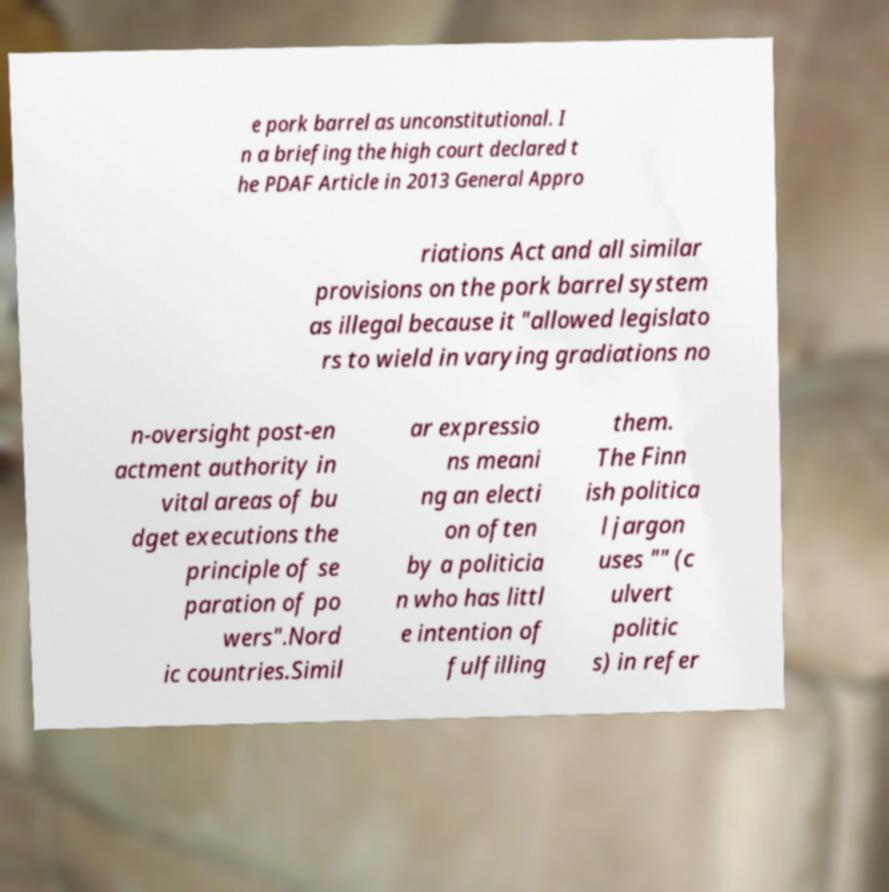There's text embedded in this image that I need extracted. Can you transcribe it verbatim? e pork barrel as unconstitutional. I n a briefing the high court declared t he PDAF Article in 2013 General Appro riations Act and all similar provisions on the pork barrel system as illegal because it "allowed legislato rs to wield in varying gradiations no n-oversight post-en actment authority in vital areas of bu dget executions the principle of se paration of po wers".Nord ic countries.Simil ar expressio ns meani ng an electi on often by a politicia n who has littl e intention of fulfilling them. The Finn ish politica l jargon uses "" (c ulvert politic s) in refer 